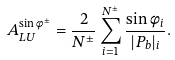Convert formula to latex. <formula><loc_0><loc_0><loc_500><loc_500>A ^ { \sin { \phi } ^ { \pm } } _ { L U } = \frac { 2 } { N ^ { \pm } } \sum ^ { N ^ { \pm } } _ { i = 1 } \frac { \sin \phi _ { i } } { | P _ { b } | _ { i } } .</formula> 